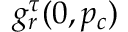<formula> <loc_0><loc_0><loc_500><loc_500>g _ { r } ^ { \tau } ( 0 , p _ { c } )</formula> 